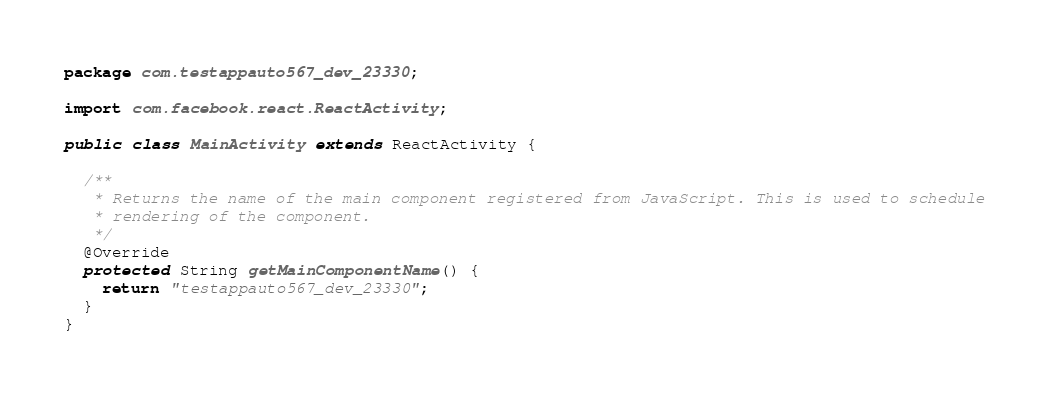Convert code to text. <code><loc_0><loc_0><loc_500><loc_500><_Java_>package com.testappauto567_dev_23330;

import com.facebook.react.ReactActivity;

public class MainActivity extends ReactActivity {

  /**
   * Returns the name of the main component registered from JavaScript. This is used to schedule
   * rendering of the component.
   */
  @Override
  protected String getMainComponentName() {
    return "testappauto567_dev_23330";
  }
}
</code> 